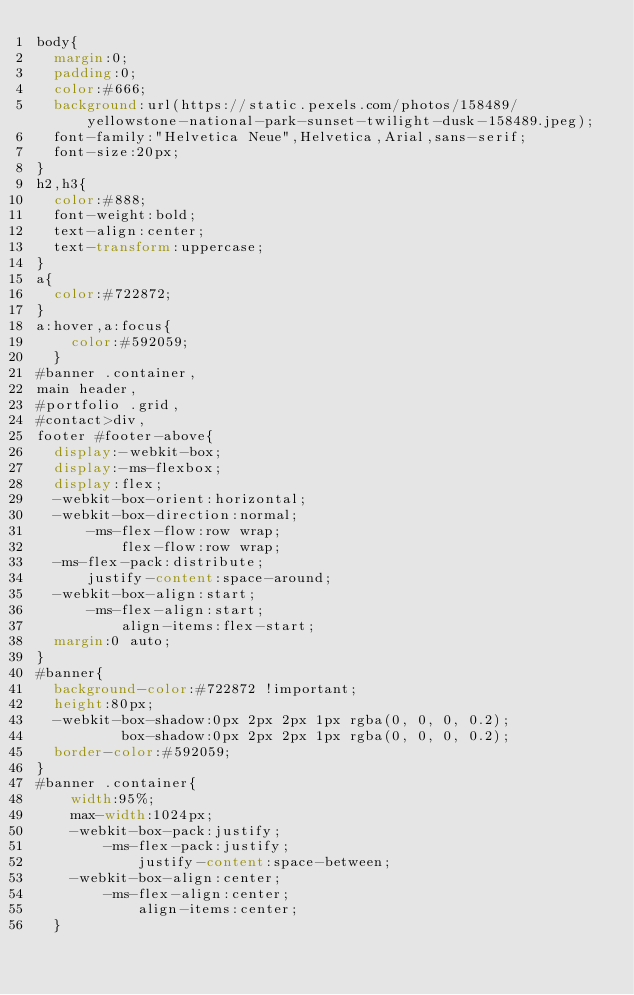<code> <loc_0><loc_0><loc_500><loc_500><_CSS_>body{
  margin:0;
  padding:0;
  color:#666;
  background:url(https://static.pexels.com/photos/158489/yellowstone-national-park-sunset-twilight-dusk-158489.jpeg);
  font-family:"Helvetica Neue",Helvetica,Arial,sans-serif;
  font-size:20px;
}
h2,h3{
  color:#888;
  font-weight:bold;
  text-align:center;
  text-transform:uppercase;
}
a{
  color:#722872;
}
a:hover,a:focus{
    color:#592059;
  }
#banner .container, 
main header, 
#portfolio .grid, 
#contact>div,
footer #footer-above{
  display:-webkit-box;
  display:-ms-flexbox;
  display:flex;
  -webkit-box-orient:horizontal;
  -webkit-box-direction:normal;
      -ms-flex-flow:row wrap;
          flex-flow:row wrap;
  -ms-flex-pack:distribute;
      justify-content:space-around;
  -webkit-box-align:start;
      -ms-flex-align:start;
          align-items:flex-start;
  margin:0 auto; 
}
#banner{
  background-color:#722872 !important;
  height:80px;
  -webkit-box-shadow:0px 2px 2px 1px rgba(0, 0, 0, 0.2);
          box-shadow:0px 2px 2px 1px rgba(0, 0, 0, 0.2);
  border-color:#592059;
}
#banner .container{
    width:95%;
    max-width:1024px;
    -webkit-box-pack:justify;
        -ms-flex-pack:justify;
            justify-content:space-between;
    -webkit-box-align:center;
        -ms-flex-align:center;
            align-items:center;
  }</code> 